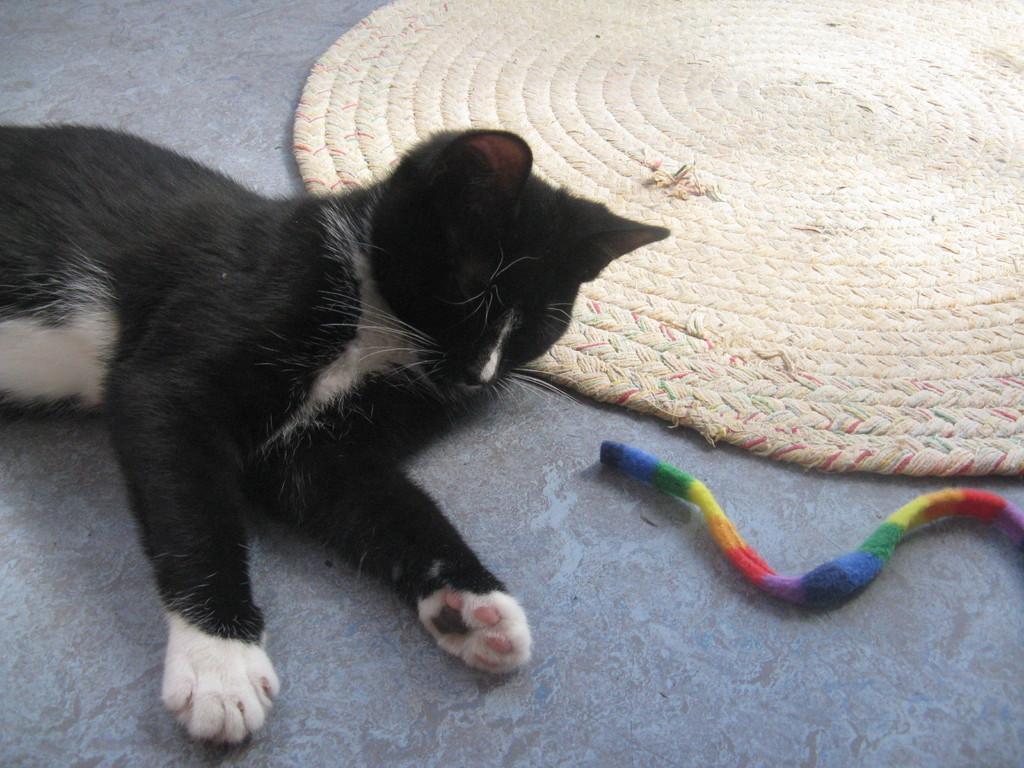Could you give a brief overview of what you see in this image? In this image we can see a cat sleeping on the floor and beside the cat there is a mat and a there is a thread with different colors in front of the cat. 